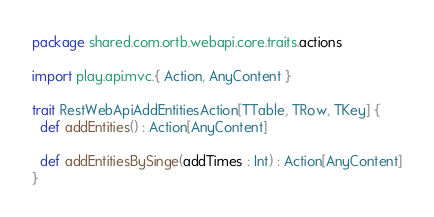<code> <loc_0><loc_0><loc_500><loc_500><_Scala_>package shared.com.ortb.webapi.core.traits.actions

import play.api.mvc.{ Action, AnyContent }

trait RestWebApiAddEntitiesAction[TTable, TRow, TKey] {
  def addEntities() : Action[AnyContent]

  def addEntitiesBySinge(addTimes : Int) : Action[AnyContent]
}
</code> 